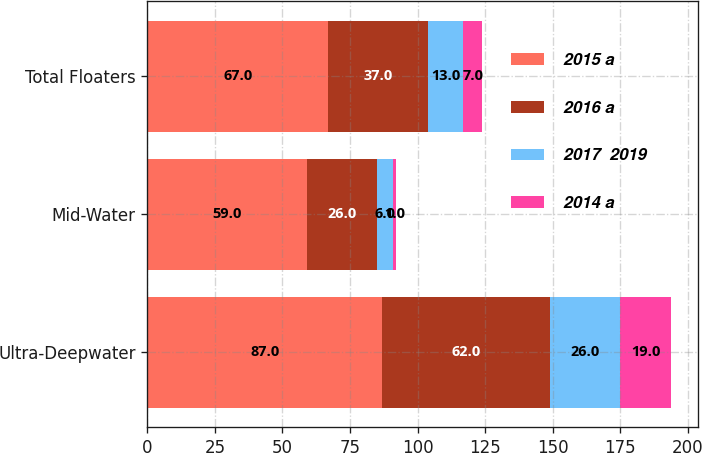Convert chart. <chart><loc_0><loc_0><loc_500><loc_500><stacked_bar_chart><ecel><fcel>Ultra-Deepwater<fcel>Mid-Water<fcel>Total Floaters<nl><fcel>2015 a<fcel>87<fcel>59<fcel>67<nl><fcel>2016 a<fcel>62<fcel>26<fcel>37<nl><fcel>2017  2019<fcel>26<fcel>6<fcel>13<nl><fcel>2014 a<fcel>19<fcel>1<fcel>7<nl></chart> 